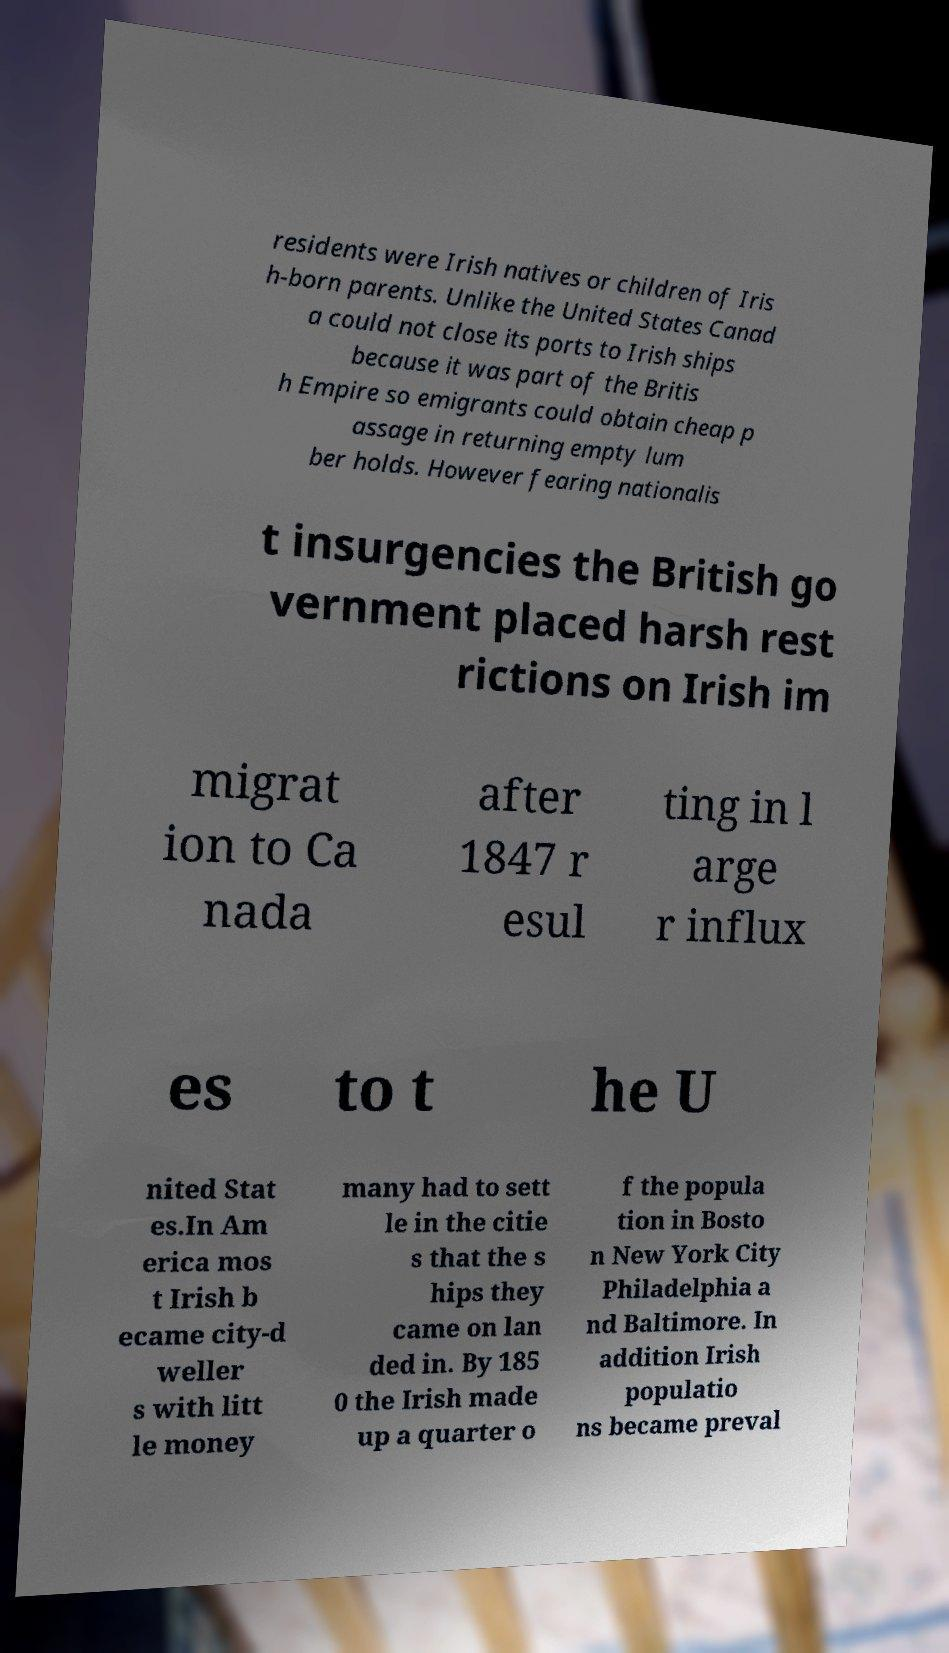What messages or text are displayed in this image? I need them in a readable, typed format. residents were Irish natives or children of Iris h-born parents. Unlike the United States Canad a could not close its ports to Irish ships because it was part of the Britis h Empire so emigrants could obtain cheap p assage in returning empty lum ber holds. However fearing nationalis t insurgencies the British go vernment placed harsh rest rictions on Irish im migrat ion to Ca nada after 1847 r esul ting in l arge r influx es to t he U nited Stat es.In Am erica mos t Irish b ecame city-d weller s with litt le money many had to sett le in the citie s that the s hips they came on lan ded in. By 185 0 the Irish made up a quarter o f the popula tion in Bosto n New York City Philadelphia a nd Baltimore. In addition Irish populatio ns became preval 